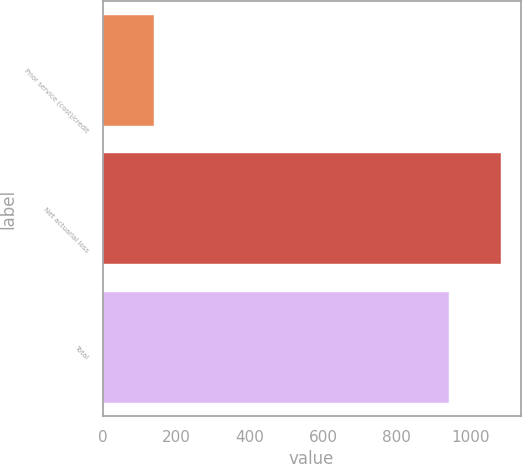Convert chart to OTSL. <chart><loc_0><loc_0><loc_500><loc_500><bar_chart><fcel>Prior service (cost)/credit<fcel>Net actuarial loss<fcel>Total<nl><fcel>139<fcel>1082<fcel>943<nl></chart> 